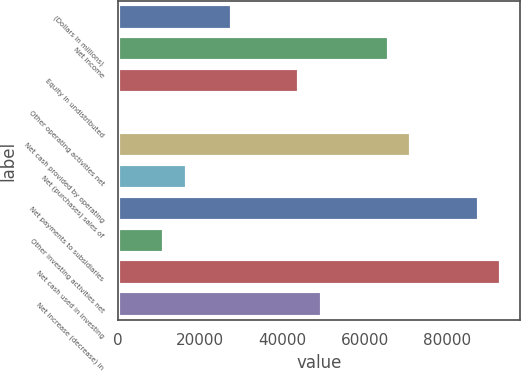Convert chart. <chart><loc_0><loc_0><loc_500><loc_500><bar_chart><fcel>(Dollars in millions)<fcel>Net income<fcel>Equity in undistributed<fcel>Other operating activities net<fcel>Net cash provided by operating<fcel>Net (purchases) sales of<fcel>Net payments to subsidiaries<fcel>Other investing activities net<fcel>Net cash used in investing<fcel>Net increase (decrease) in<nl><fcel>27632.5<fcel>65931.6<fcel>44046.4<fcel>276<fcel>71402.9<fcel>16689.9<fcel>87816.8<fcel>11218.6<fcel>93288.1<fcel>49517.7<nl></chart> 